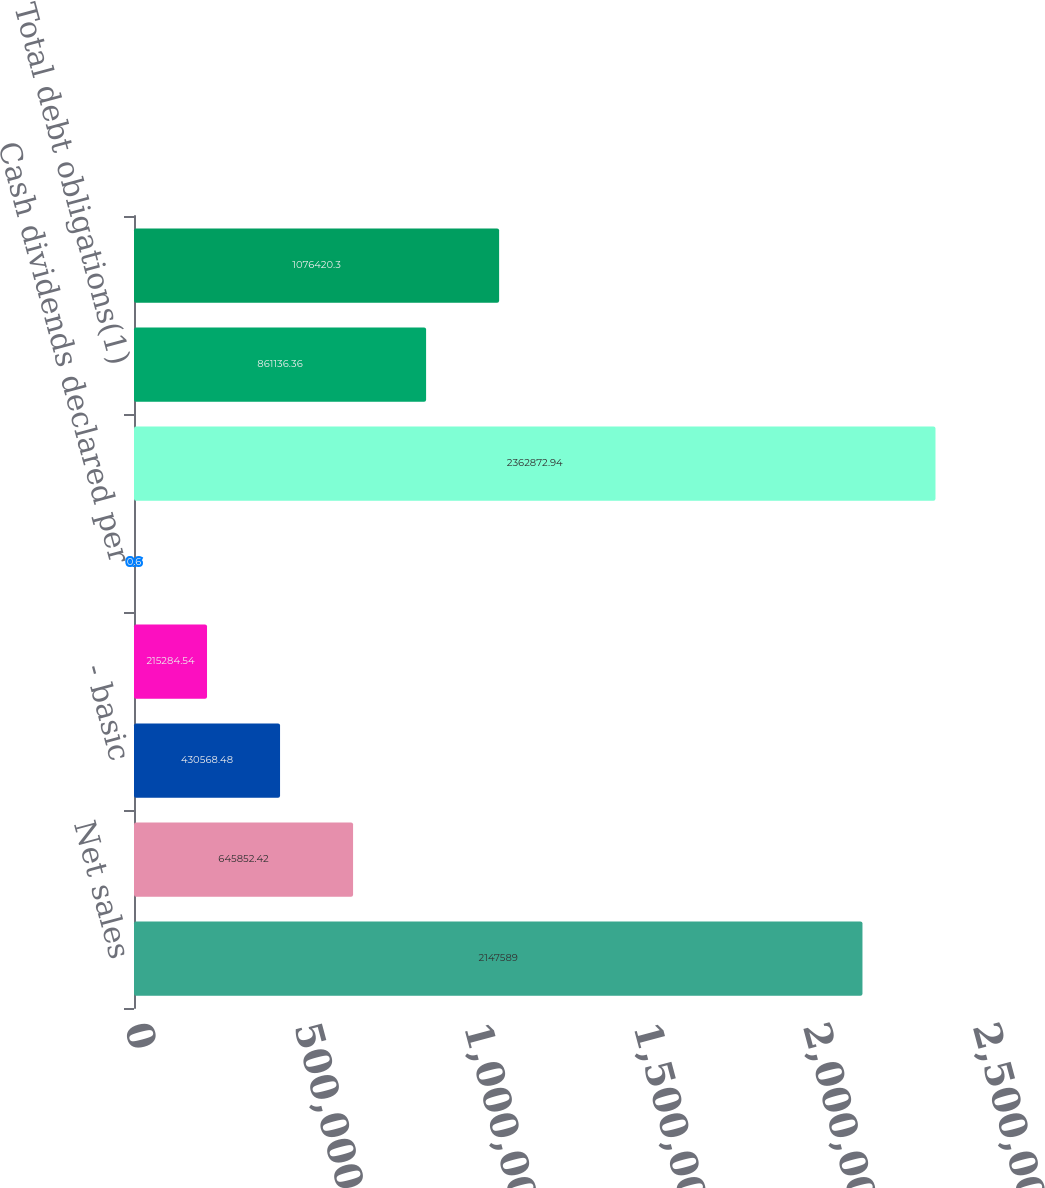Convert chart to OTSL. <chart><loc_0><loc_0><loc_500><loc_500><bar_chart><fcel>Net sales<fcel>Net income<fcel>- basic<fcel>- diluted<fcel>Cash dividends declared per<fcel>Total assets<fcel>Total debt obligations(1)<fcel>Stockholders' equity<nl><fcel>2.14759e+06<fcel>645852<fcel>430568<fcel>215285<fcel>0.6<fcel>2.36287e+06<fcel>861136<fcel>1.07642e+06<nl></chart> 